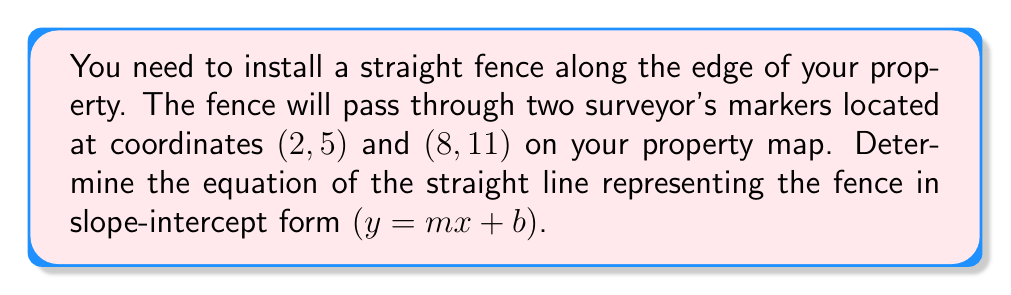What is the answer to this math problem? To find the equation of a straight line given two points, we'll follow these steps:

1. Calculate the slope (m) using the slope formula:
   $$m = \frac{y_2 - y_1}{x_2 - x_1}$$
   where $(x_1, y_1)$ is the first point and $(x_2, y_2)$ is the second point.

   $$m = \frac{11 - 5}{8 - 2} = \frac{6}{6} = 1$$

2. Use the point-slope form of a line with one of the given points:
   $$y - y_1 = m(x - x_1)$$

   Let's use the point (2, 5):
   $$y - 5 = 1(x - 2)$$

3. Simplify the equation:
   $$y - 5 = x - 2$$
   $$y = x - 2 + 5$$
   $$y = x + 3$$

4. The equation is now in slope-intercept form ($y = mx + b$), where $m = 1$ and $b = 3$.

[asy]
unitsize(1cm);
draw((-1,-1)--(10,12), arrow=Arrow(TeXHead));
draw((-1,-1)--(10,-1), arrow=Arrow(TeXHead));
draw((2,5)--(8,11), linewidth(2));
dot((2,5));
dot((8,11));
label("(2,5)", (2,5), SW);
label("(8,11)", (8,11), NE);
label("x", (10,-1), E);
label("y", (10,12), N);
[/asy]
Answer: $y = x + 3$ 